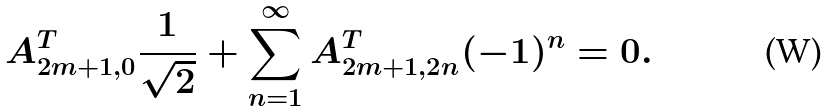Convert formula to latex. <formula><loc_0><loc_0><loc_500><loc_500>A _ { 2 m + 1 , 0 } ^ { T } \frac { 1 } { \sqrt { 2 } } + \sum _ { n = 1 } ^ { \infty } A _ { 2 m + 1 , 2 n } ^ { T } ( - 1 ) ^ { n } = 0 .</formula> 